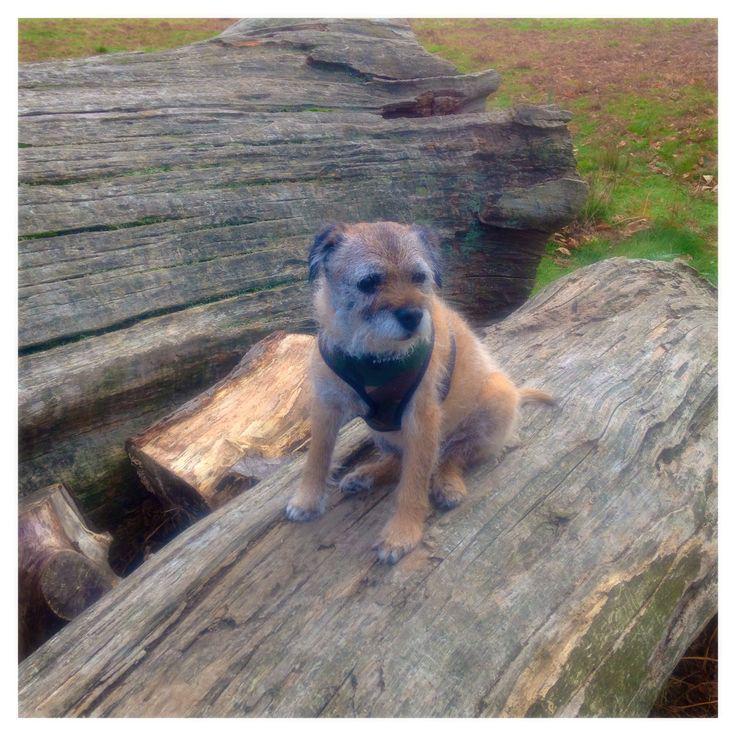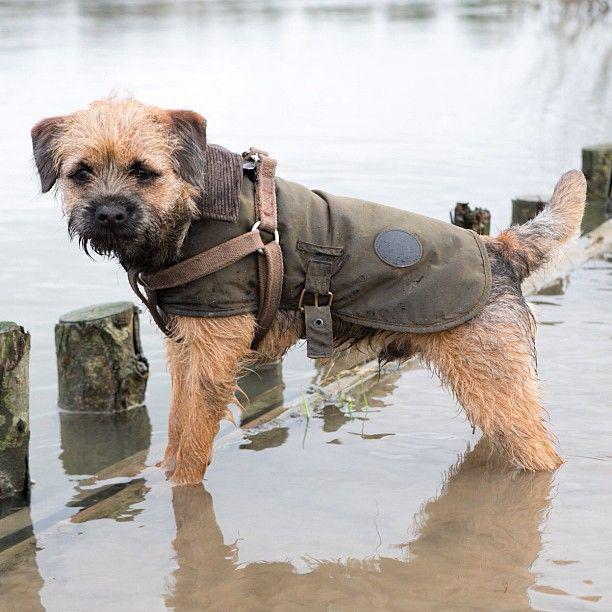The first image is the image on the left, the second image is the image on the right. Assess this claim about the two images: "dogs are leaping in the water". Correct or not? Answer yes or no. No. The first image is the image on the left, the second image is the image on the right. Analyze the images presented: Is the assertion "Each image contains a wet dog in mid stride over water." valid? Answer yes or no. No. 